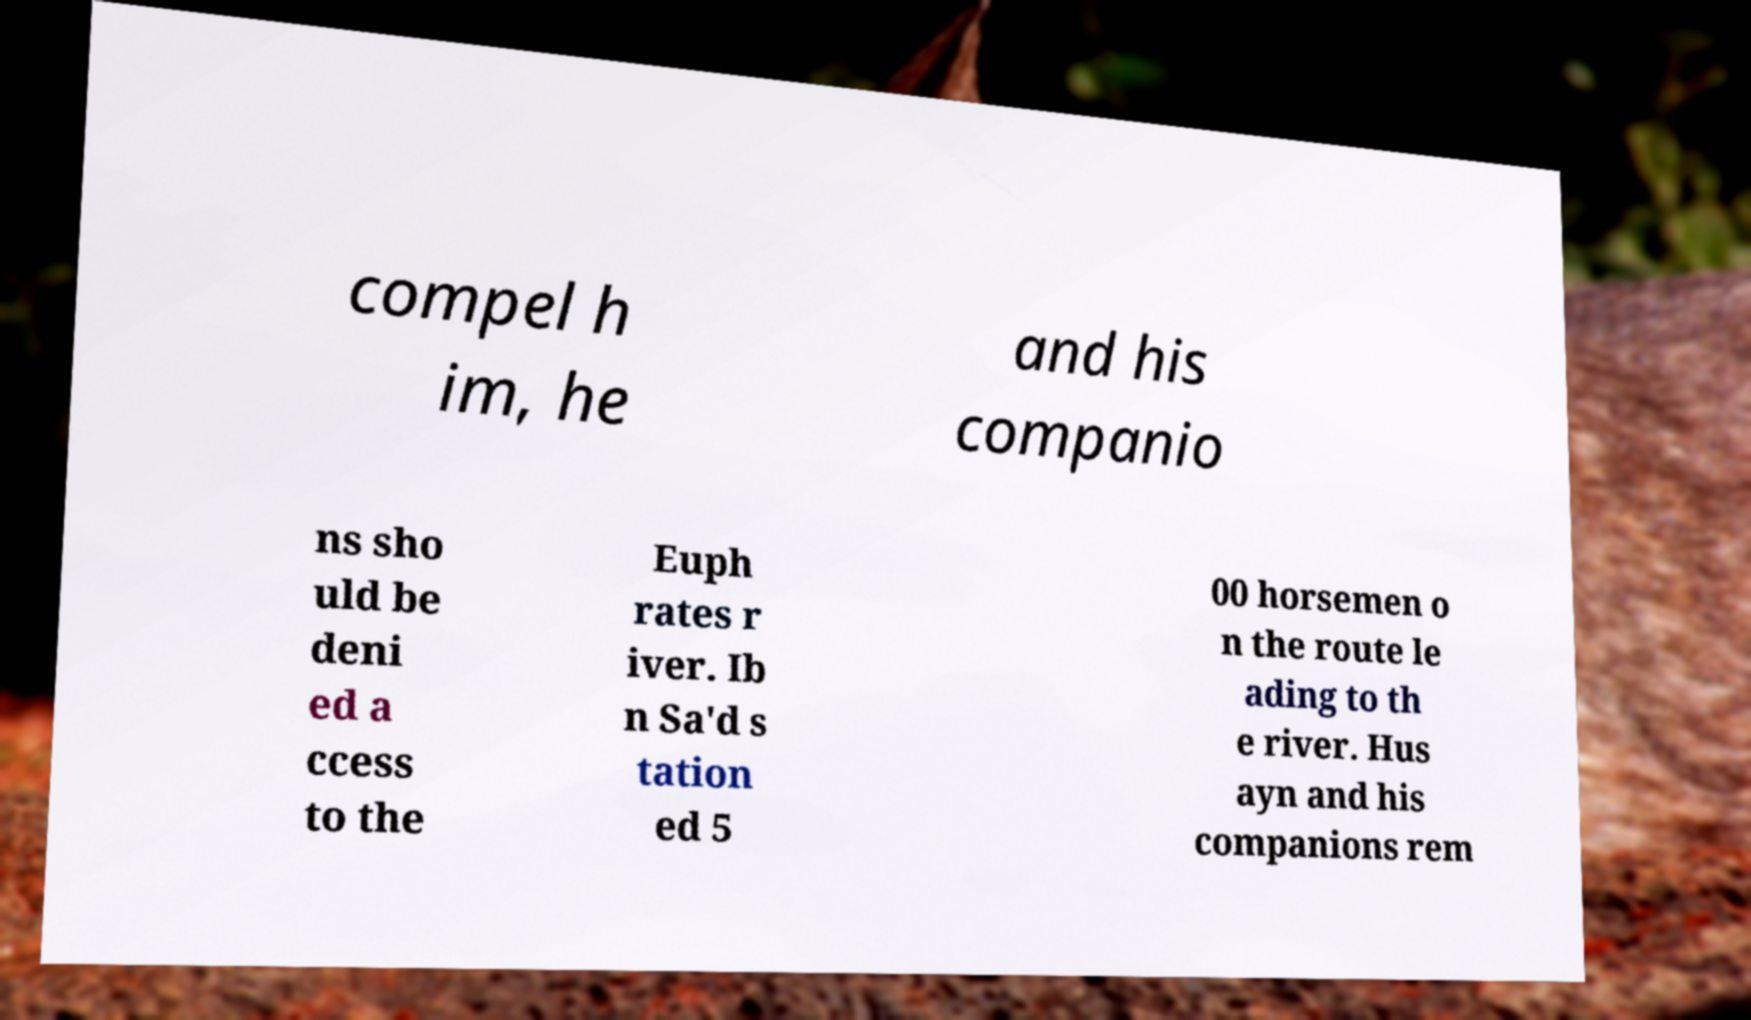Can you accurately transcribe the text from the provided image for me? compel h im, he and his companio ns sho uld be deni ed a ccess to the Euph rates r iver. Ib n Sa'd s tation ed 5 00 horsemen o n the route le ading to th e river. Hus ayn and his companions rem 